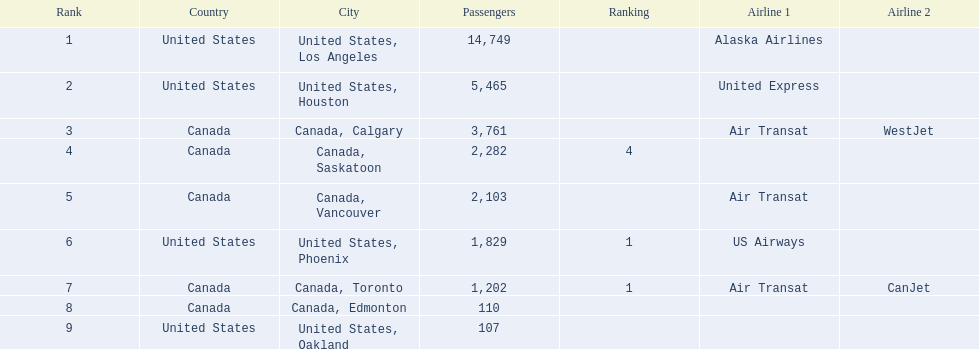Where are the destinations of the airport? United States, Los Angeles, United States, Houston, Canada, Calgary, Canada, Saskatoon, Canada, Vancouver, United States, Phoenix, Canada, Toronto, Canada, Edmonton, United States, Oakland. What is the number of passengers to phoenix? 1,829. 